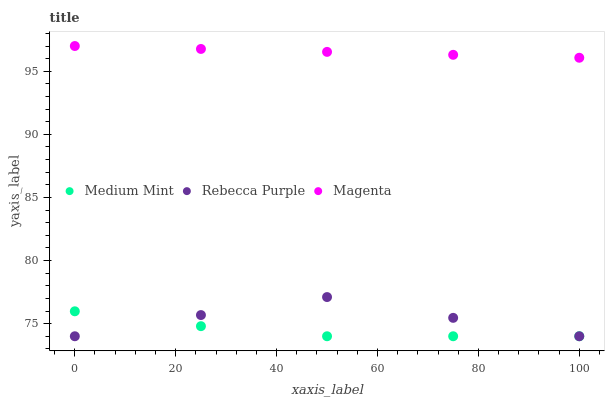Does Medium Mint have the minimum area under the curve?
Answer yes or no. Yes. Does Magenta have the maximum area under the curve?
Answer yes or no. Yes. Does Rebecca Purple have the minimum area under the curve?
Answer yes or no. No. Does Rebecca Purple have the maximum area under the curve?
Answer yes or no. No. Is Magenta the smoothest?
Answer yes or no. Yes. Is Rebecca Purple the roughest?
Answer yes or no. Yes. Is Rebecca Purple the smoothest?
Answer yes or no. No. Is Magenta the roughest?
Answer yes or no. No. Does Medium Mint have the lowest value?
Answer yes or no. Yes. Does Magenta have the lowest value?
Answer yes or no. No. Does Magenta have the highest value?
Answer yes or no. Yes. Does Rebecca Purple have the highest value?
Answer yes or no. No. Is Medium Mint less than Magenta?
Answer yes or no. Yes. Is Magenta greater than Rebecca Purple?
Answer yes or no. Yes. Does Rebecca Purple intersect Medium Mint?
Answer yes or no. Yes. Is Rebecca Purple less than Medium Mint?
Answer yes or no. No. Is Rebecca Purple greater than Medium Mint?
Answer yes or no. No. Does Medium Mint intersect Magenta?
Answer yes or no. No. 